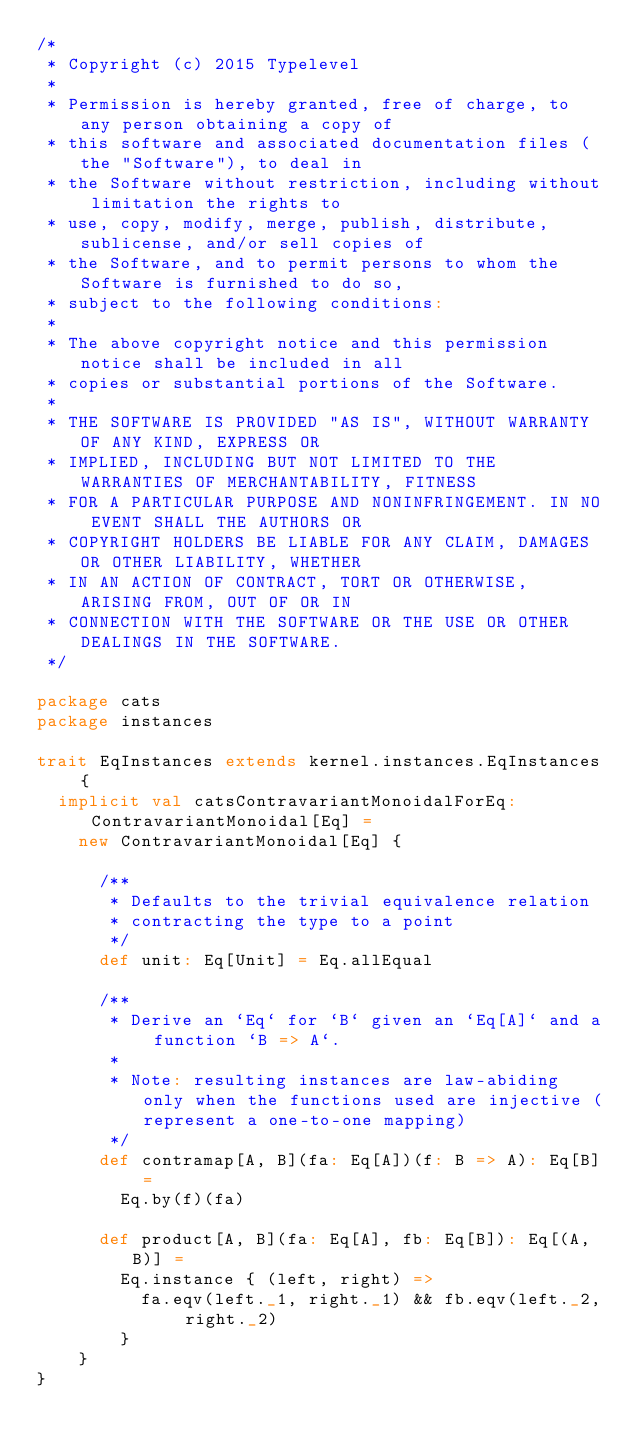Convert code to text. <code><loc_0><loc_0><loc_500><loc_500><_Scala_>/*
 * Copyright (c) 2015 Typelevel
 *
 * Permission is hereby granted, free of charge, to any person obtaining a copy of
 * this software and associated documentation files (the "Software"), to deal in
 * the Software without restriction, including without limitation the rights to
 * use, copy, modify, merge, publish, distribute, sublicense, and/or sell copies of
 * the Software, and to permit persons to whom the Software is furnished to do so,
 * subject to the following conditions:
 *
 * The above copyright notice and this permission notice shall be included in all
 * copies or substantial portions of the Software.
 *
 * THE SOFTWARE IS PROVIDED "AS IS", WITHOUT WARRANTY OF ANY KIND, EXPRESS OR
 * IMPLIED, INCLUDING BUT NOT LIMITED TO THE WARRANTIES OF MERCHANTABILITY, FITNESS
 * FOR A PARTICULAR PURPOSE AND NONINFRINGEMENT. IN NO EVENT SHALL THE AUTHORS OR
 * COPYRIGHT HOLDERS BE LIABLE FOR ANY CLAIM, DAMAGES OR OTHER LIABILITY, WHETHER
 * IN AN ACTION OF CONTRACT, TORT OR OTHERWISE, ARISING FROM, OUT OF OR IN
 * CONNECTION WITH THE SOFTWARE OR THE USE OR OTHER DEALINGS IN THE SOFTWARE.
 */

package cats
package instances

trait EqInstances extends kernel.instances.EqInstances {
  implicit val catsContravariantMonoidalForEq: ContravariantMonoidal[Eq] =
    new ContravariantMonoidal[Eq] {

      /**
       * Defaults to the trivial equivalence relation
       * contracting the type to a point
       */
      def unit: Eq[Unit] = Eq.allEqual

      /**
       * Derive an `Eq` for `B` given an `Eq[A]` and a function `B => A`.
       *
       * Note: resulting instances are law-abiding only when the functions used are injective (represent a one-to-one mapping)
       */
      def contramap[A, B](fa: Eq[A])(f: B => A): Eq[B] =
        Eq.by(f)(fa)

      def product[A, B](fa: Eq[A], fb: Eq[B]): Eq[(A, B)] =
        Eq.instance { (left, right) =>
          fa.eqv(left._1, right._1) && fb.eqv(left._2, right._2)
        }
    }
}
</code> 